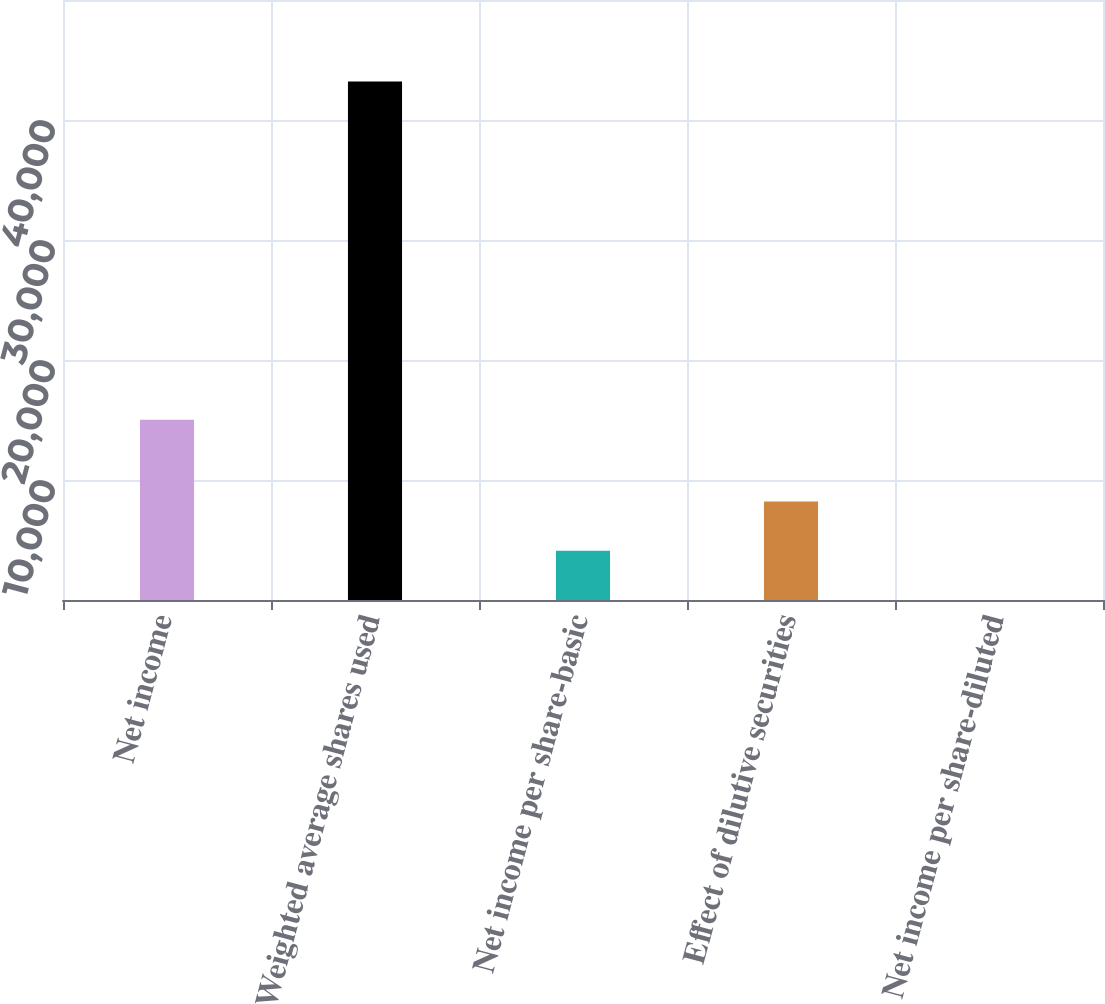<chart> <loc_0><loc_0><loc_500><loc_500><bar_chart><fcel>Net income<fcel>Weighted average shares used<fcel>Net income per share-basic<fcel>Effect of dilutive securities<fcel>Net income per share-diluted<nl><fcel>15014<fcel>43218.2<fcel>4105.53<fcel>8210.69<fcel>0.37<nl></chart> 